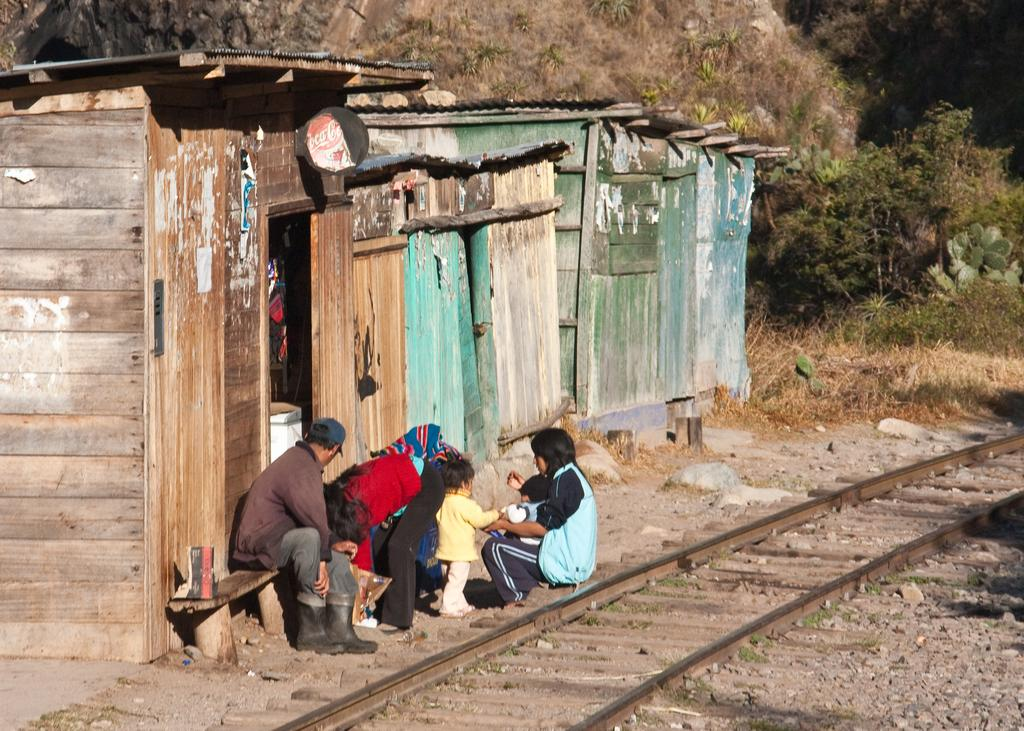What is the main activity of the people in the image? The people in the image are on the ground, but their specific activity is not mentioned in the facts. What type of transportation infrastructure is present in the image? There is a railway track in the image. What type of seating is available in the image? There is a bench in the image. What type of natural elements are present in the image? There are stones and plants in the image. What type of structures are present in the image? There are sheds in the image. What other objects are present in the image? There are some objects in the image, but their specific nature is not mentioned in the facts. What type of vegetation can be seen in the background of the image? There are trees in the background of the image. What type of art can be seen on the oven in the image? There is no oven present in the image, so it is not possible to answer that question. 